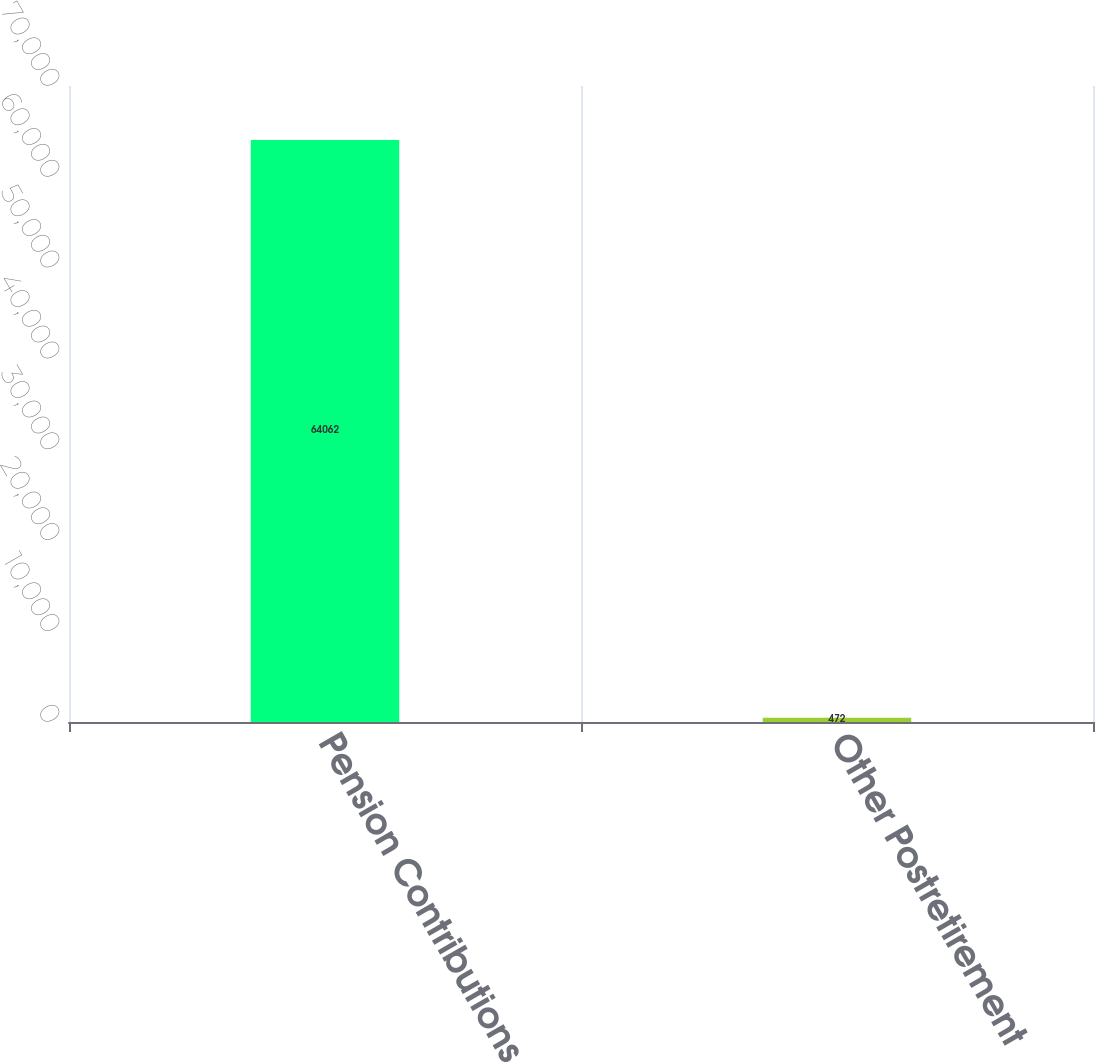Convert chart to OTSL. <chart><loc_0><loc_0><loc_500><loc_500><bar_chart><fcel>Pension Contributions<fcel>Other Postretirement<nl><fcel>64062<fcel>472<nl></chart> 